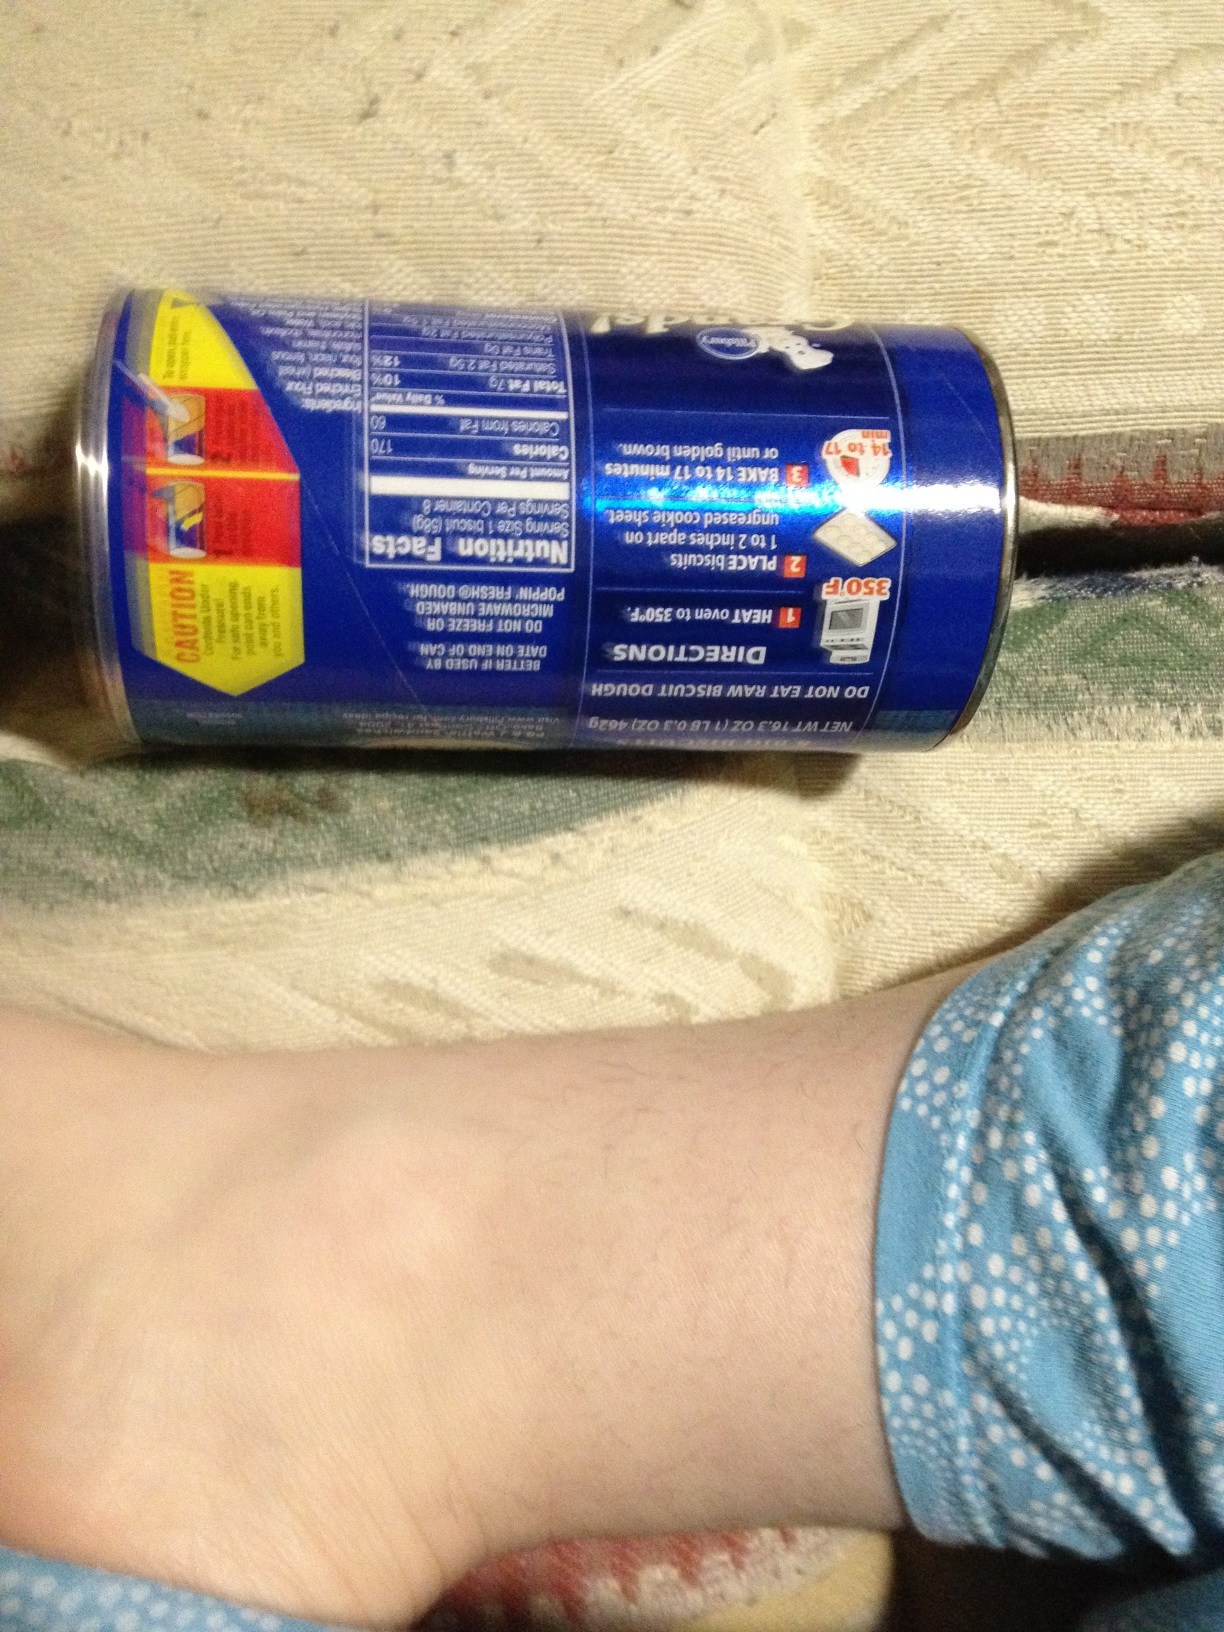Could you provide the nutritional information of these biscuits? The can shows the following nutritional facts per serving: calories 170, fat 6g (9% DV), sodium 470mg (20% DV), total carbohydrates 24g (8% DV), protein 3g. It also suggests baking the biscuits at 350°F for 14-17 minutes. 